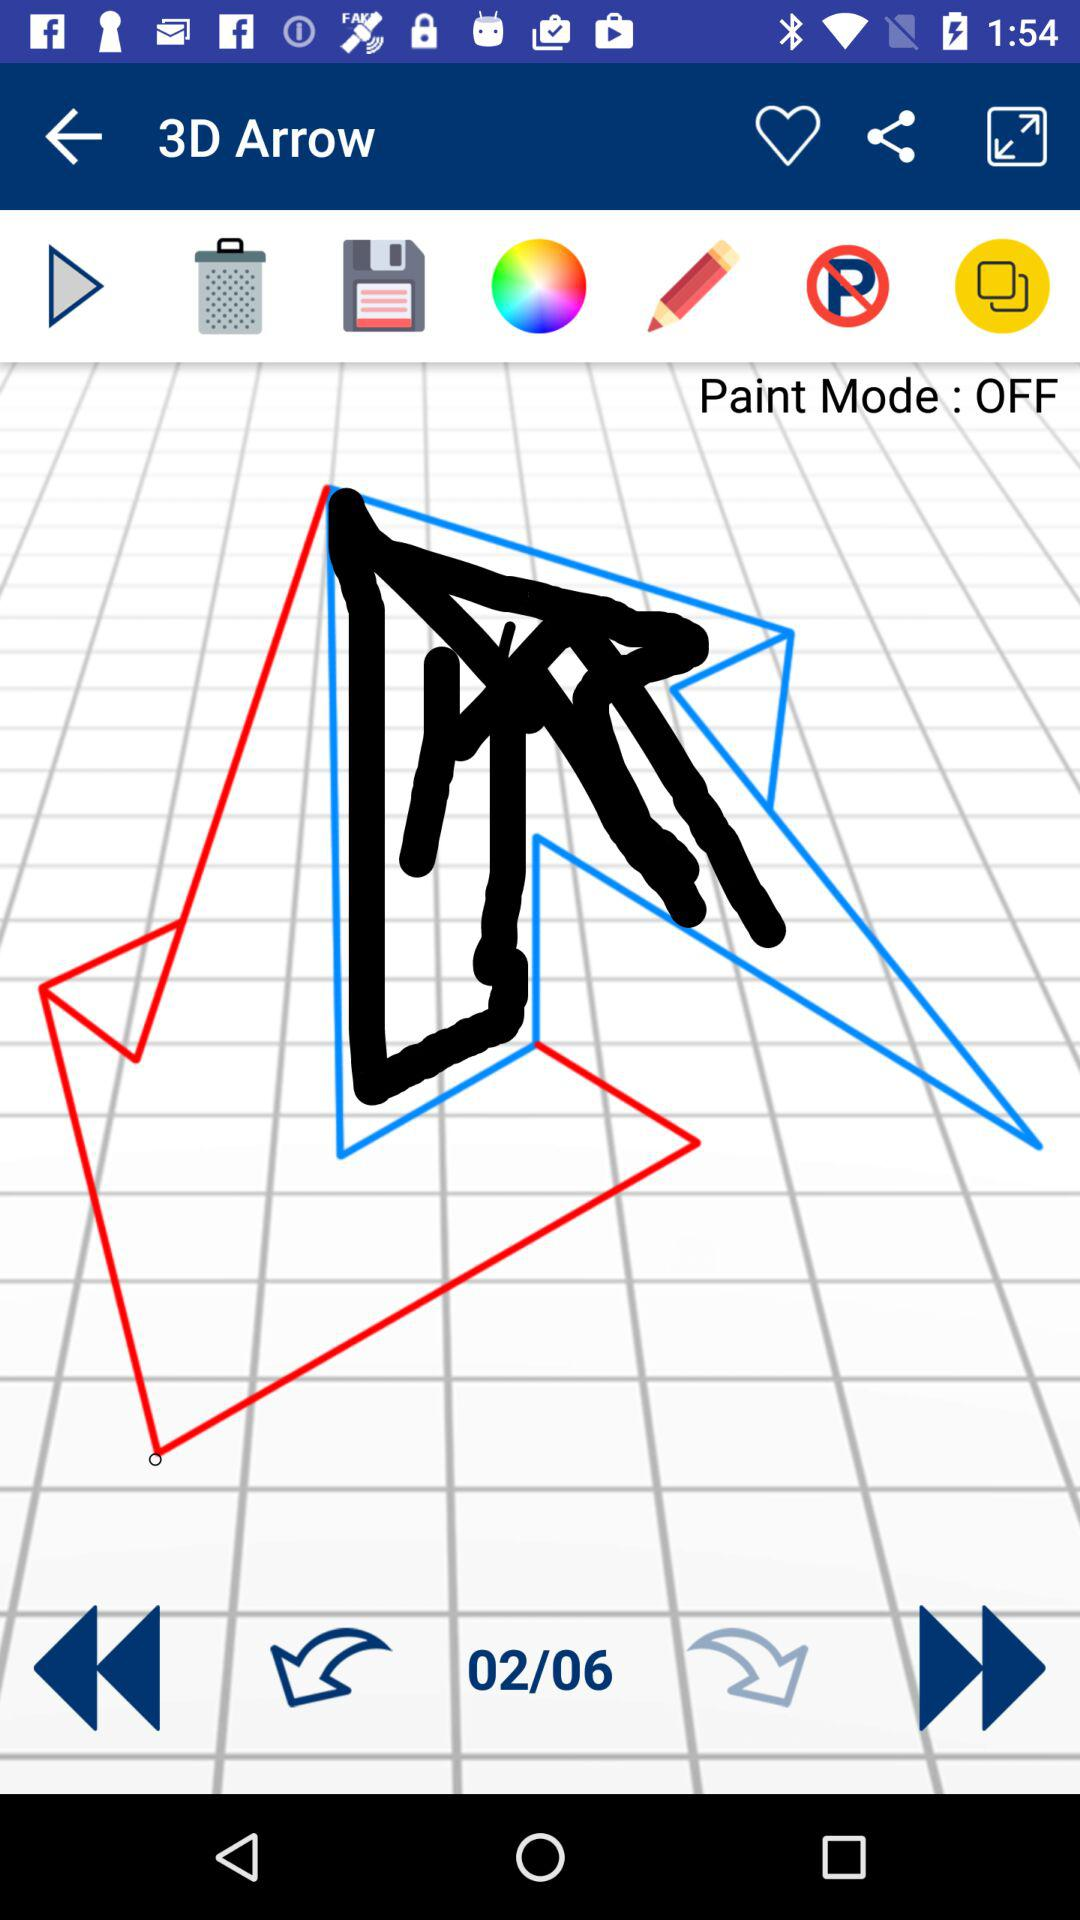At which number are we right now? Right now, you are at number 2. 